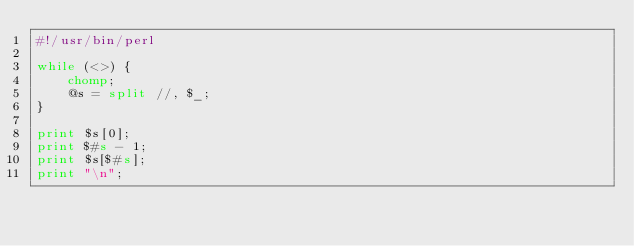Convert code to text. <code><loc_0><loc_0><loc_500><loc_500><_Perl_>#!/usr/bin/perl

while (<>) {
    chomp;
    @s = split //, $_;
}

print $s[0];
print $#s - 1;
print $s[$#s];
print "\n";
</code> 